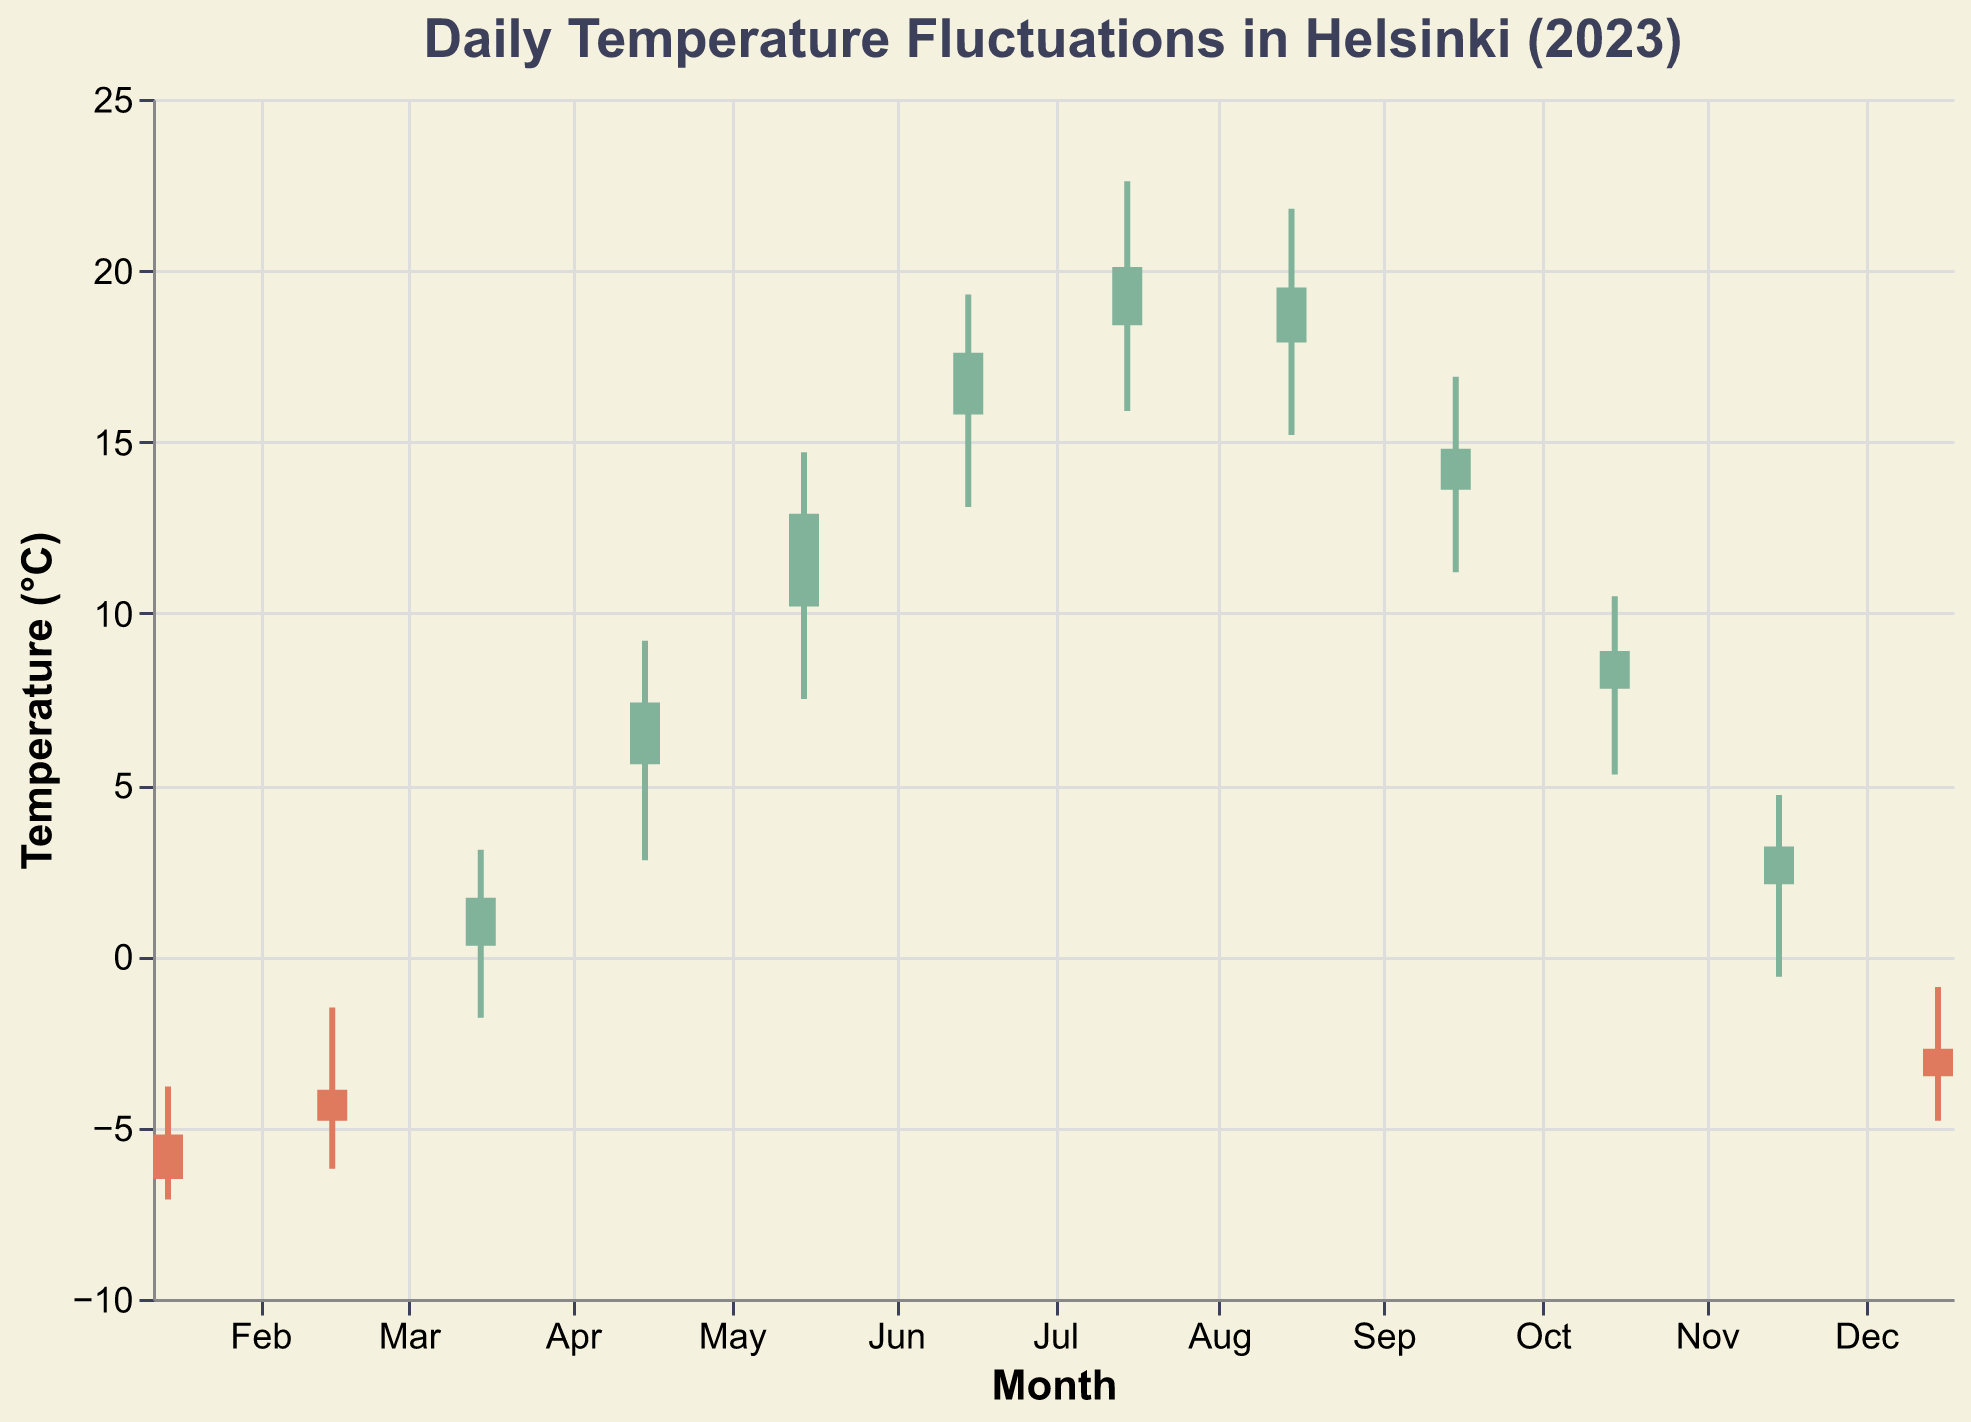What is the title of the chart? The title of the chart is written at the top of the figure.
Answer: Daily Temperature Fluctuations in Helsinki (2023) What month shows the highest recorded temperature? The highest recorded temperature can be identified by looking at the topmost bar for the "High" value.
Answer: July What is the temperature range (High-Low) for February? The temperature range is calculated by subtracting the "Low" value from the "High" value for February. In February, the High is -1.5 and the Low is -6.2, so the range is -1.5 minus -6.2, which equals 4.7.
Answer: 4.7°C Which month has the lowest opening temperature? The lowest opening temperature is identified by looking at the "Open" value across all months. The lowest value is in January with an opening temperature of -5.2°C.
Answer: January How does the temperature fluctuation in August compare to July? To compare the fluctuations, we need to look at the difference between "High" and "Low" for both months. For July: 22.6 - 15.9 = 6.7, and for August: 21.8 - 15.2 = 6.6.
Answer: July has a slightly higher fluctuation What is the closing temperature for December? The closing temperature is listed in the "Close" data point for December, which is -3.5°C.
Answer: -3.5°C On average, is the temperature higher or lower in the second half of the year compared to the first half of the year? Calculate the average temperature (Open, High, Low, Close) for each month, and then find the average for the first half (Jan-Jun) and the second half (Jul-Dec). The average for Jan-Jun is (-5.2 + -3.9 + 0.3 + 5.6 + 10.2 + 15.8 + -3.8 + -1.5 + 3.1 + 9.2 + 14.7 + 19.3 + -7.1 + -6.2 + -1.8 + 2.8 + 7.5 + 13.1 + -6.5 + -4.8 + 1.7 + 7.4 + 12.9 + 17.6) / (6 * 4) = 4.04°C. For Jul-Dec it is (18.4 + 17.9 + 13.6 + 7.8 + 2.1 + -2.7 + 22.6 + 21.8 + 16.9 + 10.5 + 4.7 + -0.9 + 15.9 + 15.2 + 11.2 + 5.3 + -0.6 + -4.8 + 20.1 + 19.5 + 14.8 + 8.9 + 3.2 + -3.5) / (6 * 4) = 10.14°C.
Answer: Higher in the second half What is the trend of temperatures from April to September? To determine the trend, visually inspect the temperatures from April to September on the chart. April begins at 5.6 and September ends at 14.8, with a consistent increase reaching a peak in July and then gradually decreasing.
Answer: Increasing to July, then decreasing Which month shows the smallest temperature range? The smallest range can be found by calculating (High - Low) for each month and finding the minimum value. In November, the range is 4.7 + 0.6 = 5.3. This is not the lowest. You should compare with other months. August has the range of 21.8 - 15.2 = 6.6 which is larger. Based on this data, January shows the smallest range -3.8 - (-7.1) = 3.3.
Answer: January 